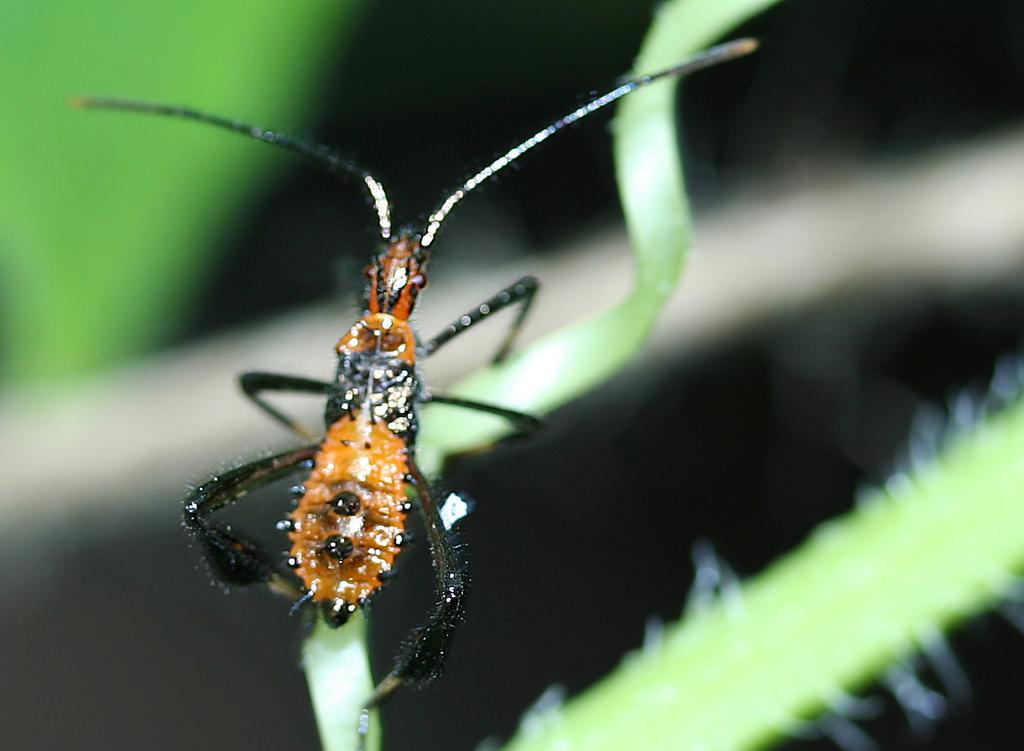What is on the leaf in the image? There is an insect on a leaf in the image. What color is the object in the image? The object in the image is white. How many green leaves are visible in the image? There are three green leaves in the image. What color is the background of the image? The background of the image is black. What is the purpose of the grandfather in the image? There is no grandfather present in the image. 